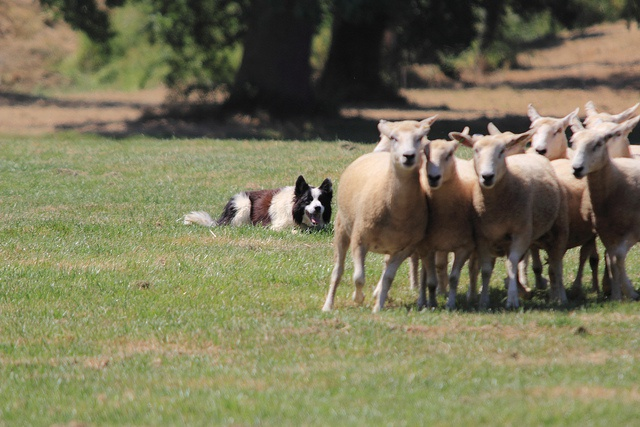Describe the objects in this image and their specific colors. I can see sheep in gray, tan, black, lightgray, and maroon tones, sheep in gray, black, and lightgray tones, sheep in gray, black, and maroon tones, sheep in gray, black, and lightgray tones, and dog in gray, black, lightgray, and darkgray tones in this image. 